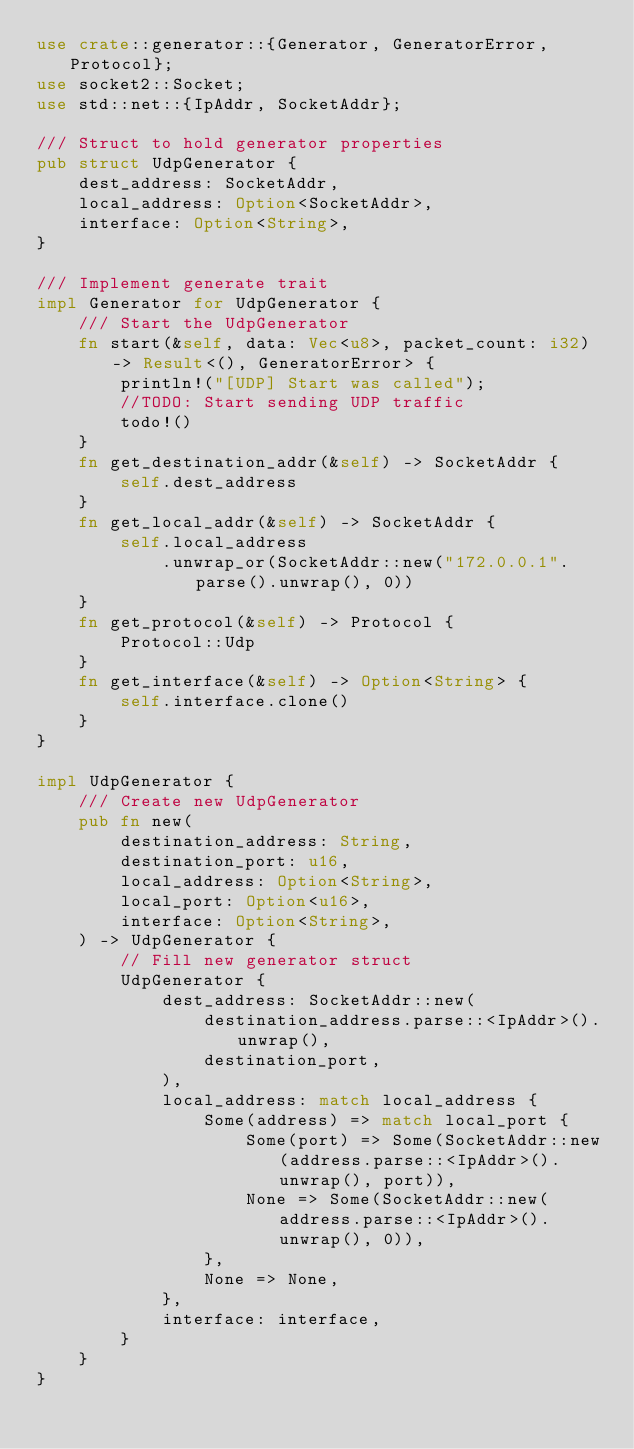Convert code to text. <code><loc_0><loc_0><loc_500><loc_500><_Rust_>use crate::generator::{Generator, GeneratorError, Protocol};
use socket2::Socket;
use std::net::{IpAddr, SocketAddr};

/// Struct to hold generator properties
pub struct UdpGenerator {
    dest_address: SocketAddr,
    local_address: Option<SocketAddr>,
    interface: Option<String>,
}

/// Implement generate trait
impl Generator for UdpGenerator {
    /// Start the UdpGenerator
    fn start(&self, data: Vec<u8>, packet_count: i32) -> Result<(), GeneratorError> {
        println!("[UDP] Start was called");
        //TODO: Start sending UDP traffic
        todo!()
    }
    fn get_destination_addr(&self) -> SocketAddr {
        self.dest_address
    }
    fn get_local_addr(&self) -> SocketAddr {
        self.local_address
            .unwrap_or(SocketAddr::new("172.0.0.1".parse().unwrap(), 0))
    }
    fn get_protocol(&self) -> Protocol {
        Protocol::Udp
    }
    fn get_interface(&self) -> Option<String> {
        self.interface.clone()
    }
}

impl UdpGenerator {
    /// Create new UdpGenerator
    pub fn new(
        destination_address: String,
        destination_port: u16,
        local_address: Option<String>,
        local_port: Option<u16>,
        interface: Option<String>,
    ) -> UdpGenerator {
        // Fill new generator struct
        UdpGenerator {
            dest_address: SocketAddr::new(
                destination_address.parse::<IpAddr>().unwrap(),
                destination_port,
            ),
            local_address: match local_address {
                Some(address) => match local_port {
                    Some(port) => Some(SocketAddr::new(address.parse::<IpAddr>().unwrap(), port)),
                    None => Some(SocketAddr::new(address.parse::<IpAddr>().unwrap(), 0)),
                },
                None => None,
            },
            interface: interface,
        }
    }
}
</code> 